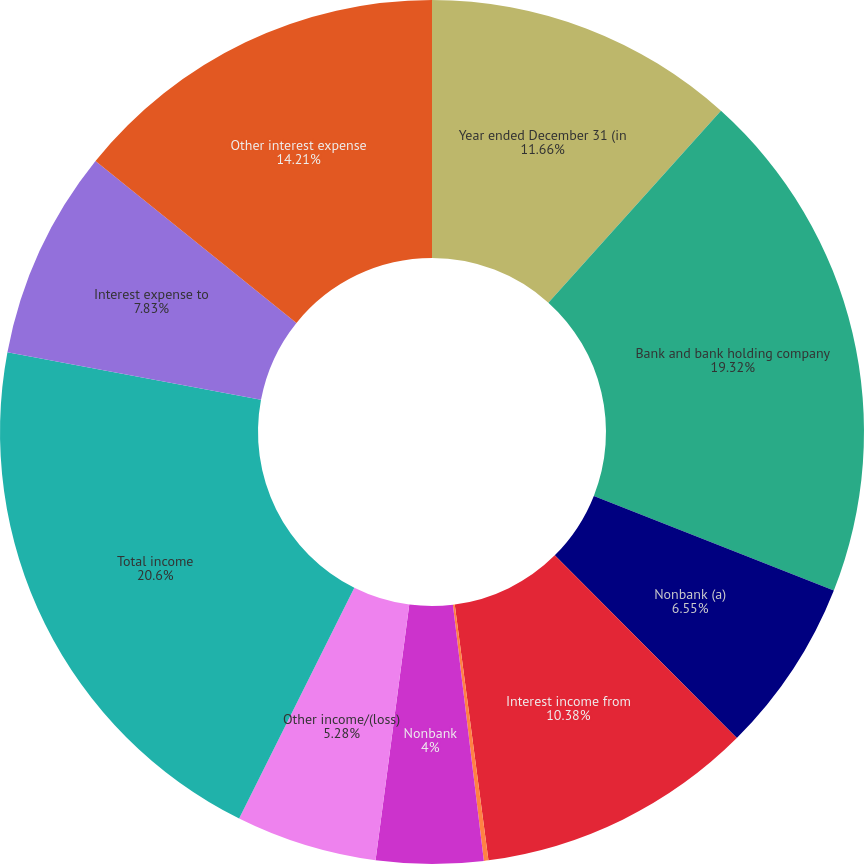Convert chart. <chart><loc_0><loc_0><loc_500><loc_500><pie_chart><fcel>Year ended December 31 (in<fcel>Bank and bank holding company<fcel>Nonbank (a)<fcel>Interest income from<fcel>Other interest income<fcel>Nonbank<fcel>Other income/(loss)<fcel>Total income<fcel>Interest expense to<fcel>Other interest expense<nl><fcel>11.66%<fcel>19.32%<fcel>6.55%<fcel>10.38%<fcel>0.17%<fcel>4.0%<fcel>5.28%<fcel>20.59%<fcel>7.83%<fcel>14.21%<nl></chart> 